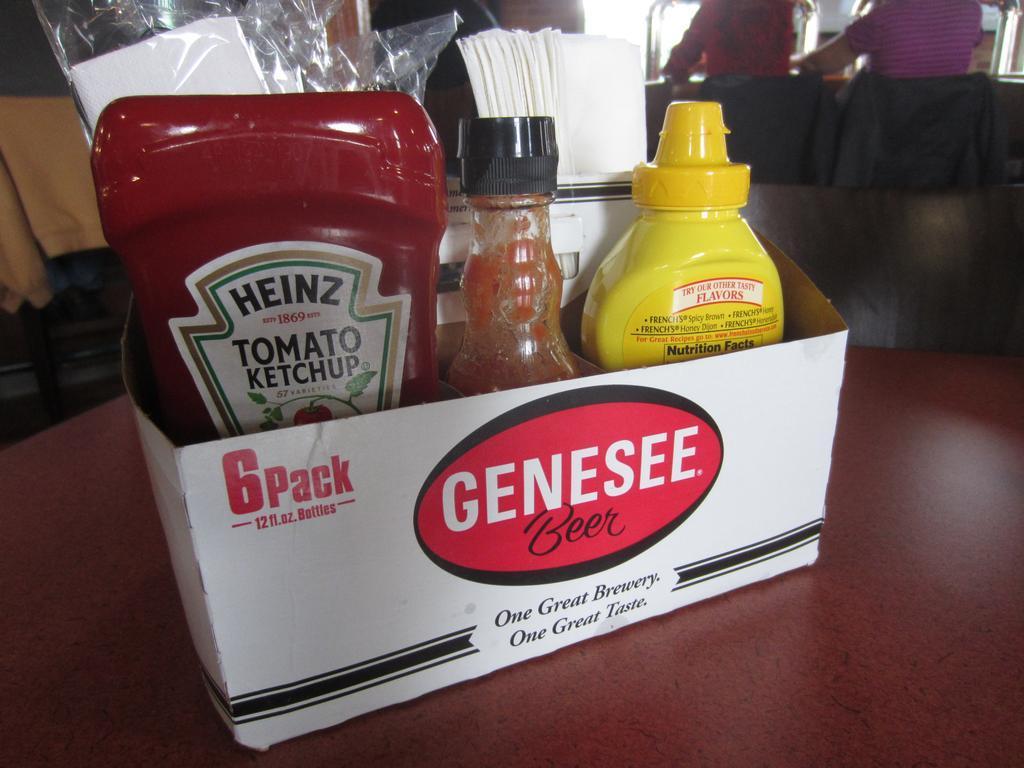What brewery is the 6 pack carton from?
Your answer should be very brief. Genesee. 